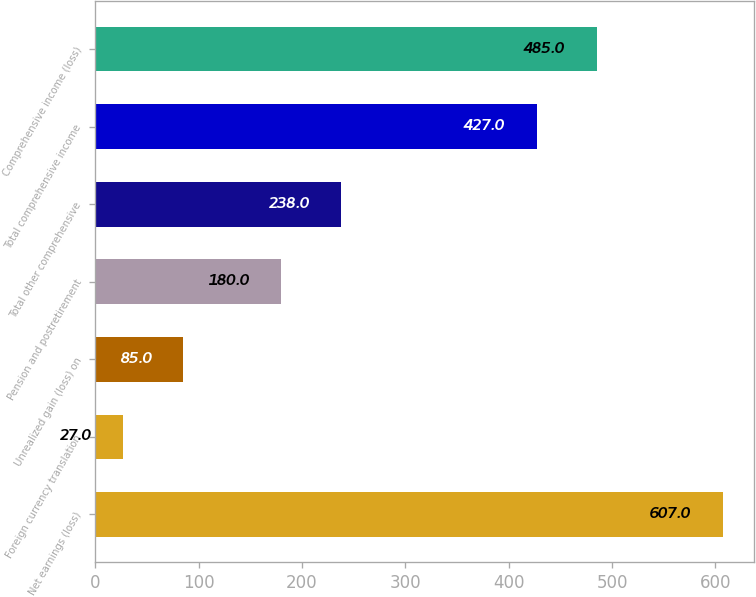Convert chart to OTSL. <chart><loc_0><loc_0><loc_500><loc_500><bar_chart><fcel>Net earnings (loss)<fcel>Foreign currency translation<fcel>Unrealized gain (loss) on<fcel>Pension and postretirement<fcel>Total other comprehensive<fcel>Total comprehensive income<fcel>Comprehensive income (loss)<nl><fcel>607<fcel>27<fcel>85<fcel>180<fcel>238<fcel>427<fcel>485<nl></chart> 